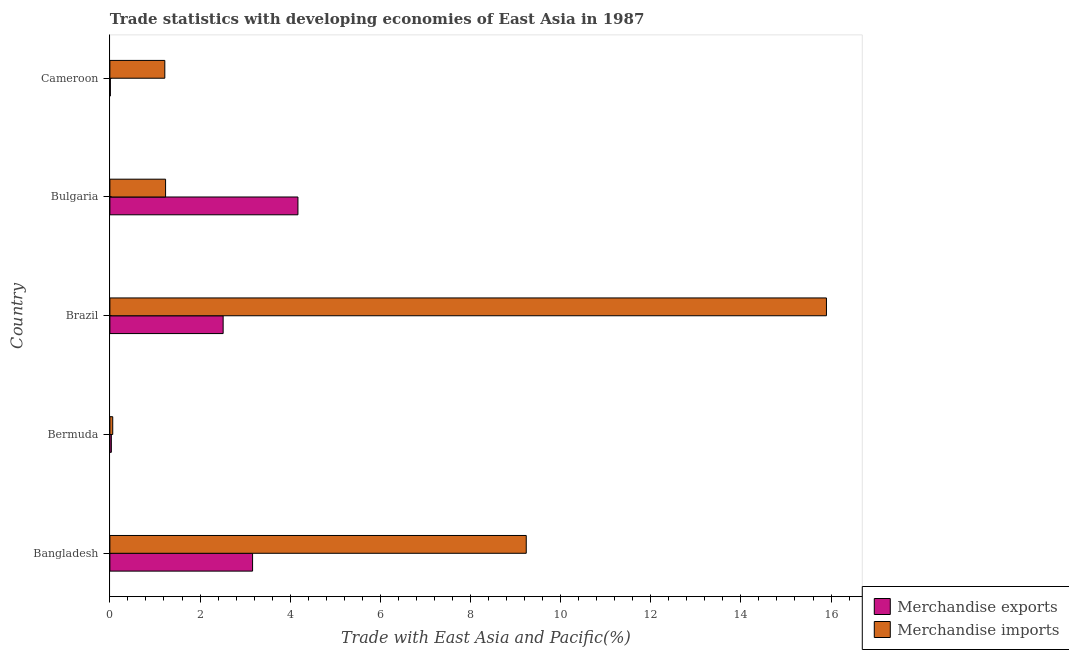How many different coloured bars are there?
Provide a succinct answer. 2. How many groups of bars are there?
Provide a short and direct response. 5. Are the number of bars on each tick of the Y-axis equal?
Your answer should be very brief. Yes. How many bars are there on the 2nd tick from the top?
Make the answer very short. 2. How many bars are there on the 5th tick from the bottom?
Your answer should be very brief. 2. What is the merchandise imports in Bulgaria?
Make the answer very short. 1.24. Across all countries, what is the maximum merchandise imports?
Offer a very short reply. 15.9. Across all countries, what is the minimum merchandise exports?
Your answer should be compact. 0.01. In which country was the merchandise exports minimum?
Offer a terse response. Cameroon. What is the total merchandise exports in the graph?
Make the answer very short. 9.89. What is the difference between the merchandise exports in Bermuda and that in Bulgaria?
Your response must be concise. -4.14. What is the difference between the merchandise imports in Bulgaria and the merchandise exports in Cameroon?
Offer a terse response. 1.23. What is the average merchandise exports per country?
Make the answer very short. 1.98. What is the difference between the merchandise imports and merchandise exports in Brazil?
Provide a succinct answer. 13.38. In how many countries, is the merchandise exports greater than 14.4 %?
Your answer should be very brief. 0. Is the merchandise imports in Bangladesh less than that in Bulgaria?
Keep it short and to the point. No. Is the difference between the merchandise imports in Bangladesh and Brazil greater than the difference between the merchandise exports in Bangladesh and Brazil?
Give a very brief answer. No. What is the difference between the highest and the lowest merchandise imports?
Provide a succinct answer. 15.83. In how many countries, is the merchandise exports greater than the average merchandise exports taken over all countries?
Offer a terse response. 3. Is the sum of the merchandise imports in Bangladesh and Bermuda greater than the maximum merchandise exports across all countries?
Provide a short and direct response. Yes. Are all the bars in the graph horizontal?
Make the answer very short. Yes. Are the values on the major ticks of X-axis written in scientific E-notation?
Offer a terse response. No. Does the graph contain any zero values?
Keep it short and to the point. No. Does the graph contain grids?
Your response must be concise. No. Where does the legend appear in the graph?
Keep it short and to the point. Bottom right. How many legend labels are there?
Your answer should be compact. 2. How are the legend labels stacked?
Your answer should be very brief. Vertical. What is the title of the graph?
Keep it short and to the point. Trade statistics with developing economies of East Asia in 1987. What is the label or title of the X-axis?
Offer a very short reply. Trade with East Asia and Pacific(%). What is the Trade with East Asia and Pacific(%) in Merchandise exports in Bangladesh?
Offer a very short reply. 3.17. What is the Trade with East Asia and Pacific(%) of Merchandise imports in Bangladesh?
Your answer should be compact. 9.24. What is the Trade with East Asia and Pacific(%) in Merchandise exports in Bermuda?
Give a very brief answer. 0.03. What is the Trade with East Asia and Pacific(%) in Merchandise imports in Bermuda?
Offer a terse response. 0.06. What is the Trade with East Asia and Pacific(%) of Merchandise exports in Brazil?
Give a very brief answer. 2.51. What is the Trade with East Asia and Pacific(%) in Merchandise imports in Brazil?
Keep it short and to the point. 15.9. What is the Trade with East Asia and Pacific(%) of Merchandise exports in Bulgaria?
Provide a succinct answer. 4.17. What is the Trade with East Asia and Pacific(%) of Merchandise imports in Bulgaria?
Your answer should be very brief. 1.24. What is the Trade with East Asia and Pacific(%) in Merchandise exports in Cameroon?
Provide a succinct answer. 0.01. What is the Trade with East Asia and Pacific(%) in Merchandise imports in Cameroon?
Ensure brevity in your answer.  1.22. Across all countries, what is the maximum Trade with East Asia and Pacific(%) of Merchandise exports?
Your answer should be very brief. 4.17. Across all countries, what is the maximum Trade with East Asia and Pacific(%) of Merchandise imports?
Make the answer very short. 15.9. Across all countries, what is the minimum Trade with East Asia and Pacific(%) in Merchandise exports?
Provide a succinct answer. 0.01. Across all countries, what is the minimum Trade with East Asia and Pacific(%) of Merchandise imports?
Keep it short and to the point. 0.06. What is the total Trade with East Asia and Pacific(%) of Merchandise exports in the graph?
Your answer should be compact. 9.89. What is the total Trade with East Asia and Pacific(%) in Merchandise imports in the graph?
Your answer should be compact. 27.65. What is the difference between the Trade with East Asia and Pacific(%) in Merchandise exports in Bangladesh and that in Bermuda?
Your answer should be compact. 3.13. What is the difference between the Trade with East Asia and Pacific(%) in Merchandise imports in Bangladesh and that in Bermuda?
Your answer should be very brief. 9.17. What is the difference between the Trade with East Asia and Pacific(%) in Merchandise exports in Bangladesh and that in Brazil?
Ensure brevity in your answer.  0.65. What is the difference between the Trade with East Asia and Pacific(%) of Merchandise imports in Bangladesh and that in Brazil?
Your answer should be very brief. -6.66. What is the difference between the Trade with East Asia and Pacific(%) of Merchandise exports in Bangladesh and that in Bulgaria?
Make the answer very short. -1.01. What is the difference between the Trade with East Asia and Pacific(%) in Merchandise imports in Bangladesh and that in Bulgaria?
Make the answer very short. 8. What is the difference between the Trade with East Asia and Pacific(%) in Merchandise exports in Bangladesh and that in Cameroon?
Provide a succinct answer. 3.16. What is the difference between the Trade with East Asia and Pacific(%) in Merchandise imports in Bangladesh and that in Cameroon?
Ensure brevity in your answer.  8.02. What is the difference between the Trade with East Asia and Pacific(%) of Merchandise exports in Bermuda and that in Brazil?
Your answer should be very brief. -2.48. What is the difference between the Trade with East Asia and Pacific(%) of Merchandise imports in Bermuda and that in Brazil?
Offer a very short reply. -15.83. What is the difference between the Trade with East Asia and Pacific(%) in Merchandise exports in Bermuda and that in Bulgaria?
Make the answer very short. -4.14. What is the difference between the Trade with East Asia and Pacific(%) in Merchandise imports in Bermuda and that in Bulgaria?
Your answer should be compact. -1.17. What is the difference between the Trade with East Asia and Pacific(%) in Merchandise exports in Bermuda and that in Cameroon?
Your response must be concise. 0.02. What is the difference between the Trade with East Asia and Pacific(%) of Merchandise imports in Bermuda and that in Cameroon?
Ensure brevity in your answer.  -1.16. What is the difference between the Trade with East Asia and Pacific(%) in Merchandise exports in Brazil and that in Bulgaria?
Your response must be concise. -1.66. What is the difference between the Trade with East Asia and Pacific(%) in Merchandise imports in Brazil and that in Bulgaria?
Your answer should be compact. 14.66. What is the difference between the Trade with East Asia and Pacific(%) in Merchandise exports in Brazil and that in Cameroon?
Make the answer very short. 2.5. What is the difference between the Trade with East Asia and Pacific(%) in Merchandise imports in Brazil and that in Cameroon?
Make the answer very short. 14.68. What is the difference between the Trade with East Asia and Pacific(%) of Merchandise exports in Bulgaria and that in Cameroon?
Your answer should be very brief. 4.16. What is the difference between the Trade with East Asia and Pacific(%) of Merchandise imports in Bulgaria and that in Cameroon?
Your response must be concise. 0.02. What is the difference between the Trade with East Asia and Pacific(%) in Merchandise exports in Bangladesh and the Trade with East Asia and Pacific(%) in Merchandise imports in Bermuda?
Offer a terse response. 3.1. What is the difference between the Trade with East Asia and Pacific(%) in Merchandise exports in Bangladesh and the Trade with East Asia and Pacific(%) in Merchandise imports in Brazil?
Make the answer very short. -12.73. What is the difference between the Trade with East Asia and Pacific(%) in Merchandise exports in Bangladesh and the Trade with East Asia and Pacific(%) in Merchandise imports in Bulgaria?
Offer a terse response. 1.93. What is the difference between the Trade with East Asia and Pacific(%) in Merchandise exports in Bangladesh and the Trade with East Asia and Pacific(%) in Merchandise imports in Cameroon?
Offer a very short reply. 1.95. What is the difference between the Trade with East Asia and Pacific(%) in Merchandise exports in Bermuda and the Trade with East Asia and Pacific(%) in Merchandise imports in Brazil?
Your answer should be compact. -15.87. What is the difference between the Trade with East Asia and Pacific(%) of Merchandise exports in Bermuda and the Trade with East Asia and Pacific(%) of Merchandise imports in Bulgaria?
Your response must be concise. -1.2. What is the difference between the Trade with East Asia and Pacific(%) in Merchandise exports in Bermuda and the Trade with East Asia and Pacific(%) in Merchandise imports in Cameroon?
Give a very brief answer. -1.19. What is the difference between the Trade with East Asia and Pacific(%) of Merchandise exports in Brazil and the Trade with East Asia and Pacific(%) of Merchandise imports in Bulgaria?
Your response must be concise. 1.28. What is the difference between the Trade with East Asia and Pacific(%) of Merchandise exports in Brazil and the Trade with East Asia and Pacific(%) of Merchandise imports in Cameroon?
Provide a short and direct response. 1.29. What is the difference between the Trade with East Asia and Pacific(%) of Merchandise exports in Bulgaria and the Trade with East Asia and Pacific(%) of Merchandise imports in Cameroon?
Your answer should be compact. 2.95. What is the average Trade with East Asia and Pacific(%) in Merchandise exports per country?
Offer a very short reply. 1.98. What is the average Trade with East Asia and Pacific(%) of Merchandise imports per country?
Your answer should be very brief. 5.53. What is the difference between the Trade with East Asia and Pacific(%) of Merchandise exports and Trade with East Asia and Pacific(%) of Merchandise imports in Bangladesh?
Your answer should be very brief. -6.07. What is the difference between the Trade with East Asia and Pacific(%) in Merchandise exports and Trade with East Asia and Pacific(%) in Merchandise imports in Bermuda?
Provide a succinct answer. -0.03. What is the difference between the Trade with East Asia and Pacific(%) in Merchandise exports and Trade with East Asia and Pacific(%) in Merchandise imports in Brazil?
Your answer should be compact. -13.39. What is the difference between the Trade with East Asia and Pacific(%) in Merchandise exports and Trade with East Asia and Pacific(%) in Merchandise imports in Bulgaria?
Give a very brief answer. 2.94. What is the difference between the Trade with East Asia and Pacific(%) of Merchandise exports and Trade with East Asia and Pacific(%) of Merchandise imports in Cameroon?
Provide a short and direct response. -1.21. What is the ratio of the Trade with East Asia and Pacific(%) of Merchandise exports in Bangladesh to that in Bermuda?
Ensure brevity in your answer.  97.79. What is the ratio of the Trade with East Asia and Pacific(%) of Merchandise imports in Bangladesh to that in Bermuda?
Offer a terse response. 146.39. What is the ratio of the Trade with East Asia and Pacific(%) in Merchandise exports in Bangladesh to that in Brazil?
Offer a terse response. 1.26. What is the ratio of the Trade with East Asia and Pacific(%) in Merchandise imports in Bangladesh to that in Brazil?
Keep it short and to the point. 0.58. What is the ratio of the Trade with East Asia and Pacific(%) of Merchandise exports in Bangladesh to that in Bulgaria?
Your answer should be compact. 0.76. What is the ratio of the Trade with East Asia and Pacific(%) of Merchandise imports in Bangladesh to that in Bulgaria?
Your answer should be very brief. 7.48. What is the ratio of the Trade with East Asia and Pacific(%) of Merchandise exports in Bangladesh to that in Cameroon?
Offer a terse response. 319.77. What is the ratio of the Trade with East Asia and Pacific(%) of Merchandise imports in Bangladesh to that in Cameroon?
Provide a succinct answer. 7.58. What is the ratio of the Trade with East Asia and Pacific(%) in Merchandise exports in Bermuda to that in Brazil?
Provide a succinct answer. 0.01. What is the ratio of the Trade with East Asia and Pacific(%) of Merchandise imports in Bermuda to that in Brazil?
Your response must be concise. 0. What is the ratio of the Trade with East Asia and Pacific(%) of Merchandise exports in Bermuda to that in Bulgaria?
Provide a succinct answer. 0.01. What is the ratio of the Trade with East Asia and Pacific(%) in Merchandise imports in Bermuda to that in Bulgaria?
Your answer should be compact. 0.05. What is the ratio of the Trade with East Asia and Pacific(%) of Merchandise exports in Bermuda to that in Cameroon?
Keep it short and to the point. 3.27. What is the ratio of the Trade with East Asia and Pacific(%) of Merchandise imports in Bermuda to that in Cameroon?
Your response must be concise. 0.05. What is the ratio of the Trade with East Asia and Pacific(%) of Merchandise exports in Brazil to that in Bulgaria?
Your answer should be compact. 0.6. What is the ratio of the Trade with East Asia and Pacific(%) in Merchandise imports in Brazil to that in Bulgaria?
Your response must be concise. 12.87. What is the ratio of the Trade with East Asia and Pacific(%) of Merchandise exports in Brazil to that in Cameroon?
Provide a short and direct response. 253.77. What is the ratio of the Trade with East Asia and Pacific(%) in Merchandise imports in Brazil to that in Cameroon?
Provide a succinct answer. 13.05. What is the ratio of the Trade with East Asia and Pacific(%) of Merchandise exports in Bulgaria to that in Cameroon?
Make the answer very short. 421.41. What is the ratio of the Trade with East Asia and Pacific(%) in Merchandise imports in Bulgaria to that in Cameroon?
Keep it short and to the point. 1.01. What is the difference between the highest and the second highest Trade with East Asia and Pacific(%) of Merchandise exports?
Your response must be concise. 1.01. What is the difference between the highest and the second highest Trade with East Asia and Pacific(%) of Merchandise imports?
Your response must be concise. 6.66. What is the difference between the highest and the lowest Trade with East Asia and Pacific(%) in Merchandise exports?
Offer a very short reply. 4.16. What is the difference between the highest and the lowest Trade with East Asia and Pacific(%) in Merchandise imports?
Ensure brevity in your answer.  15.83. 